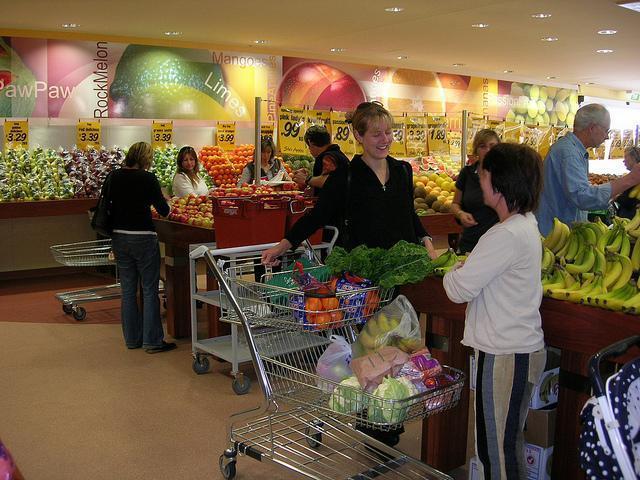How many people are there?
Give a very brief answer. 5. How many boats are in the photo?
Give a very brief answer. 0. 